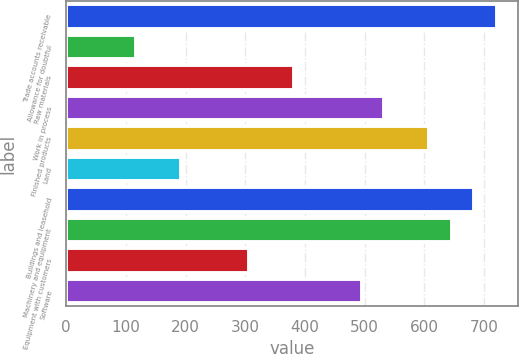<chart> <loc_0><loc_0><loc_500><loc_500><bar_chart><fcel>Trade accounts receivable<fcel>Allowance for doubtful<fcel>Raw materials<fcel>Work in process<fcel>Finished products<fcel>Land<fcel>Buildings and leasehold<fcel>Machinery and equipment<fcel>Equipment with customers<fcel>Software<nl><fcel>721.69<fcel>116.73<fcel>381.4<fcel>532.64<fcel>608.26<fcel>192.35<fcel>683.88<fcel>646.07<fcel>305.78<fcel>494.83<nl></chart> 